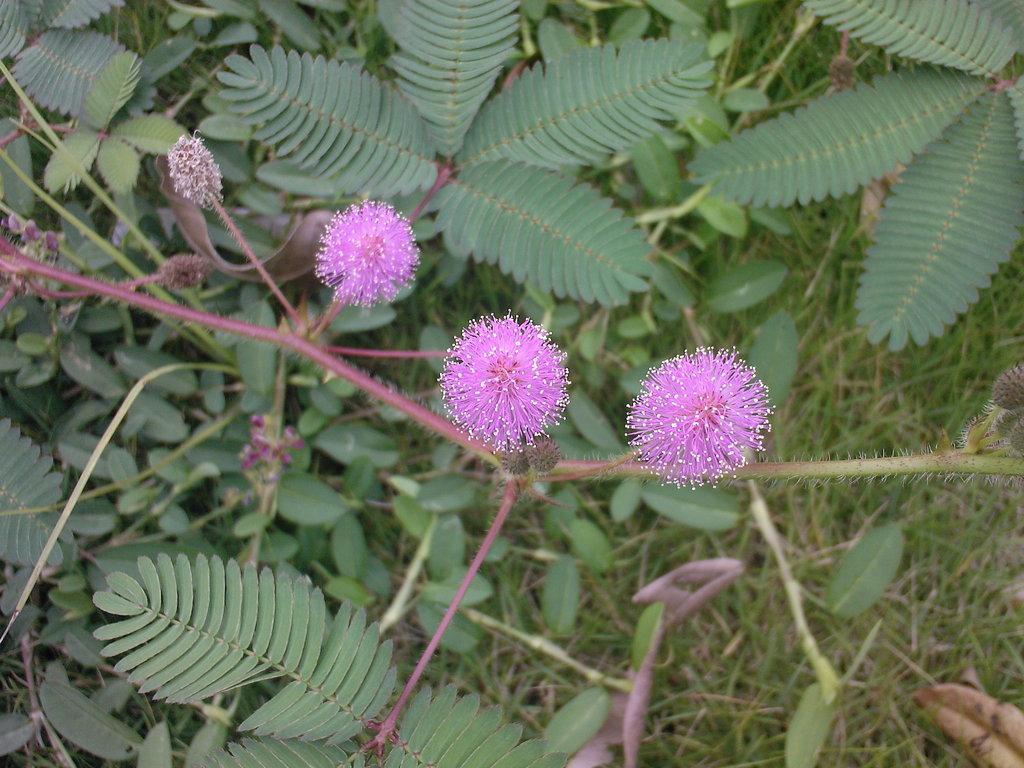Can you describe this image briefly? These are the flowers, which are purple in color. I think these are the plants with the leaves. This looks like the grass. 